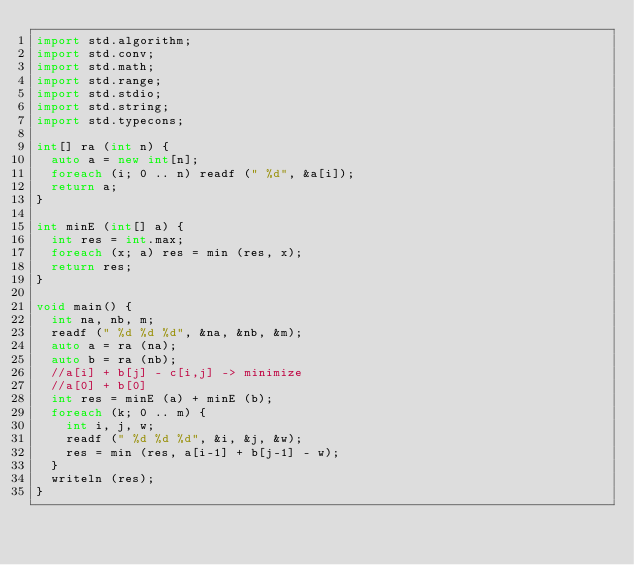<code> <loc_0><loc_0><loc_500><loc_500><_D_>import std.algorithm;
import std.conv;
import std.math;
import std.range;
import std.stdio;
import std.string;
import std.typecons;

int[] ra (int n) {
  auto a = new int[n];
  foreach (i; 0 .. n) readf (" %d", &a[i]);
  return a;
}

int minE (int[] a) {
  int res = int.max;
  foreach (x; a) res = min (res, x);
  return res;
}

void main() {
  int na, nb, m;
  readf (" %d %d %d", &na, &nb, &m);
  auto a = ra (na);
  auto b = ra (nb);
  //a[i] + b[j] - c[i,j] -> minimize
  //a[0] + b[0]
  int res = minE (a) + minE (b); 
  foreach (k; 0 .. m) {
    int i, j, w;
    readf (" %d %d %d", &i, &j, &w);
    res = min (res, a[i-1] + b[j-1] - w);
  }
  writeln (res);
}

</code> 